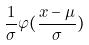Convert formula to latex. <formula><loc_0><loc_0><loc_500><loc_500>\frac { 1 } { \sigma } \varphi ( \frac { x - \mu } { \sigma } )</formula> 